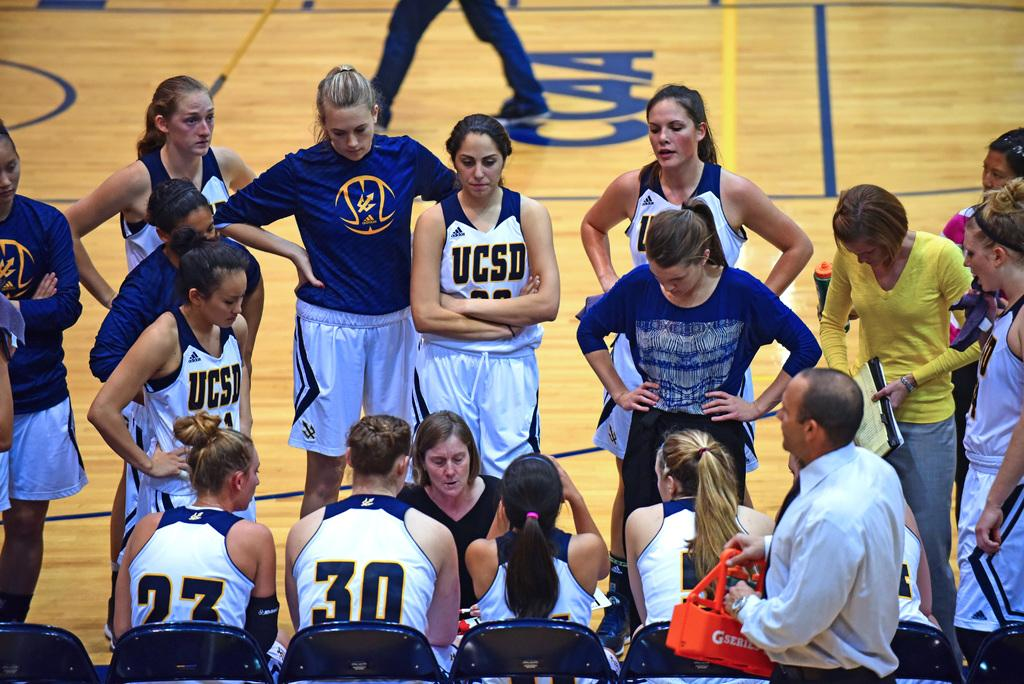<image>
Create a compact narrative representing the image presented. A group of players wearing UCSD shirts standing. 